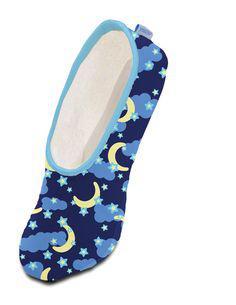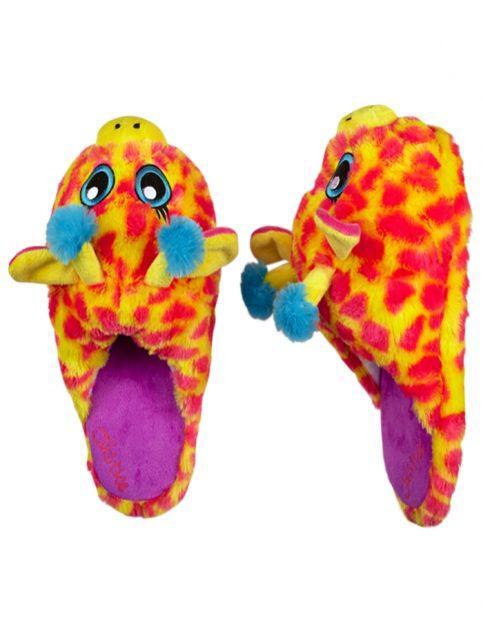The first image is the image on the left, the second image is the image on the right. Given the left and right images, does the statement "The left image contains a single print-patterned slipper without a fluffy texture, and the right image contains a pair of fluffy slippers." hold true? Answer yes or no. Yes. 